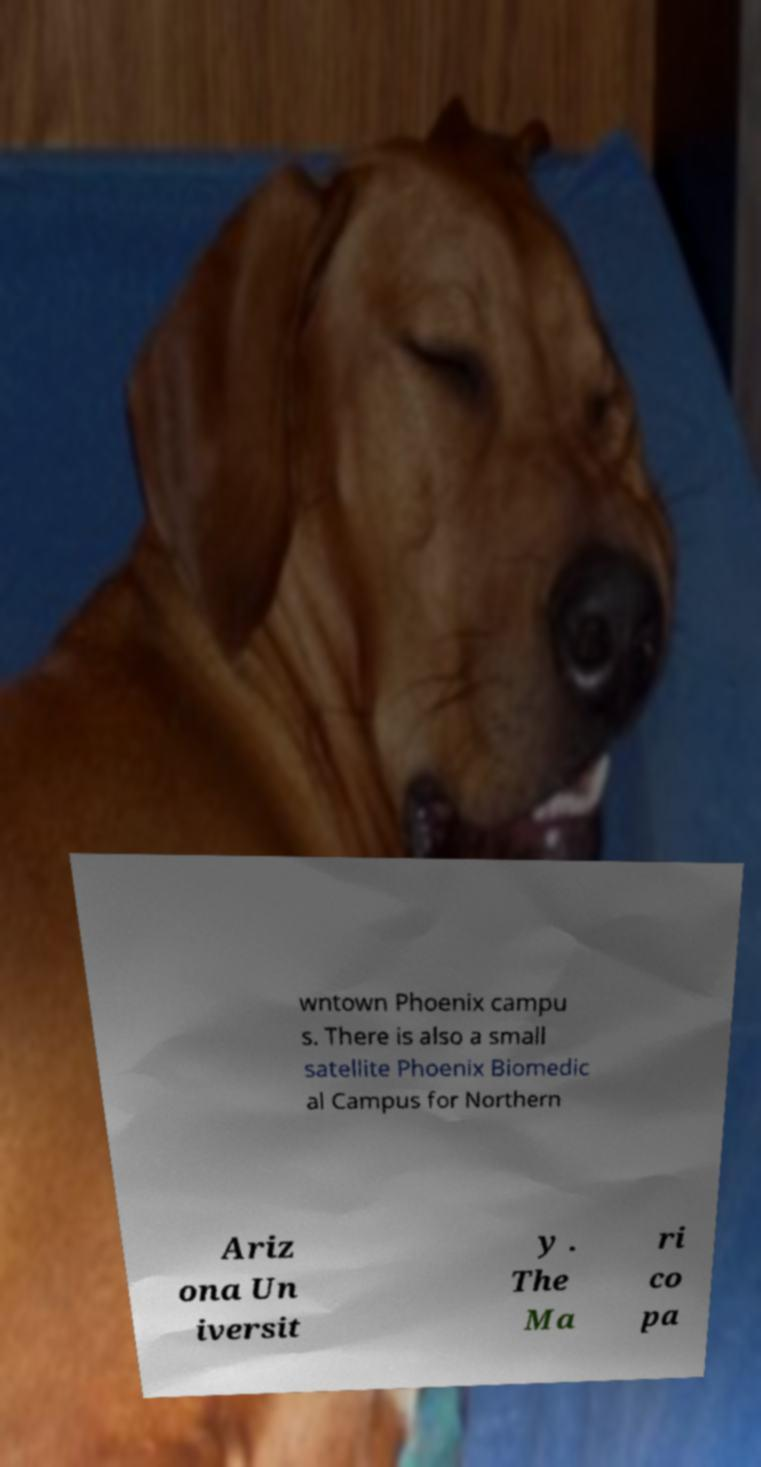What messages or text are displayed in this image? I need them in a readable, typed format. wntown Phoenix campu s. There is also a small satellite Phoenix Biomedic al Campus for Northern Ariz ona Un iversit y . The Ma ri co pa 